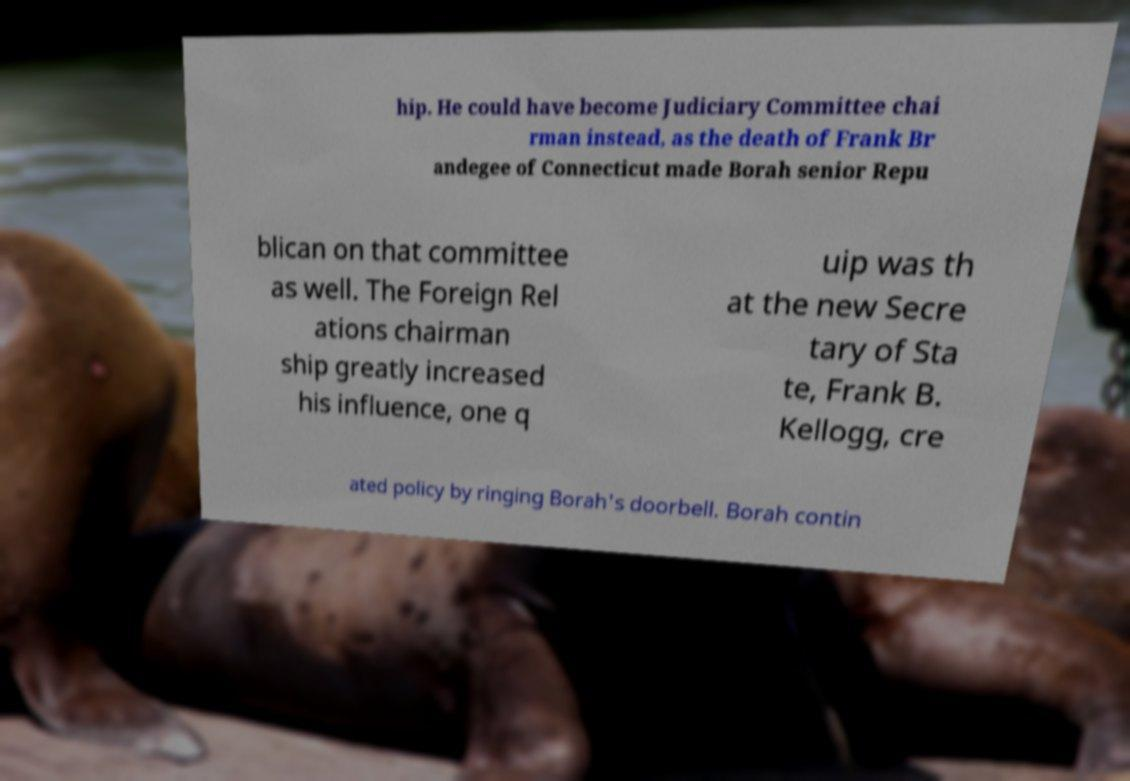Please read and relay the text visible in this image. What does it say? hip. He could have become Judiciary Committee chai rman instead, as the death of Frank Br andegee of Connecticut made Borah senior Repu blican on that committee as well. The Foreign Rel ations chairman ship greatly increased his influence, one q uip was th at the new Secre tary of Sta te, Frank B. Kellogg, cre ated policy by ringing Borah's doorbell. Borah contin 